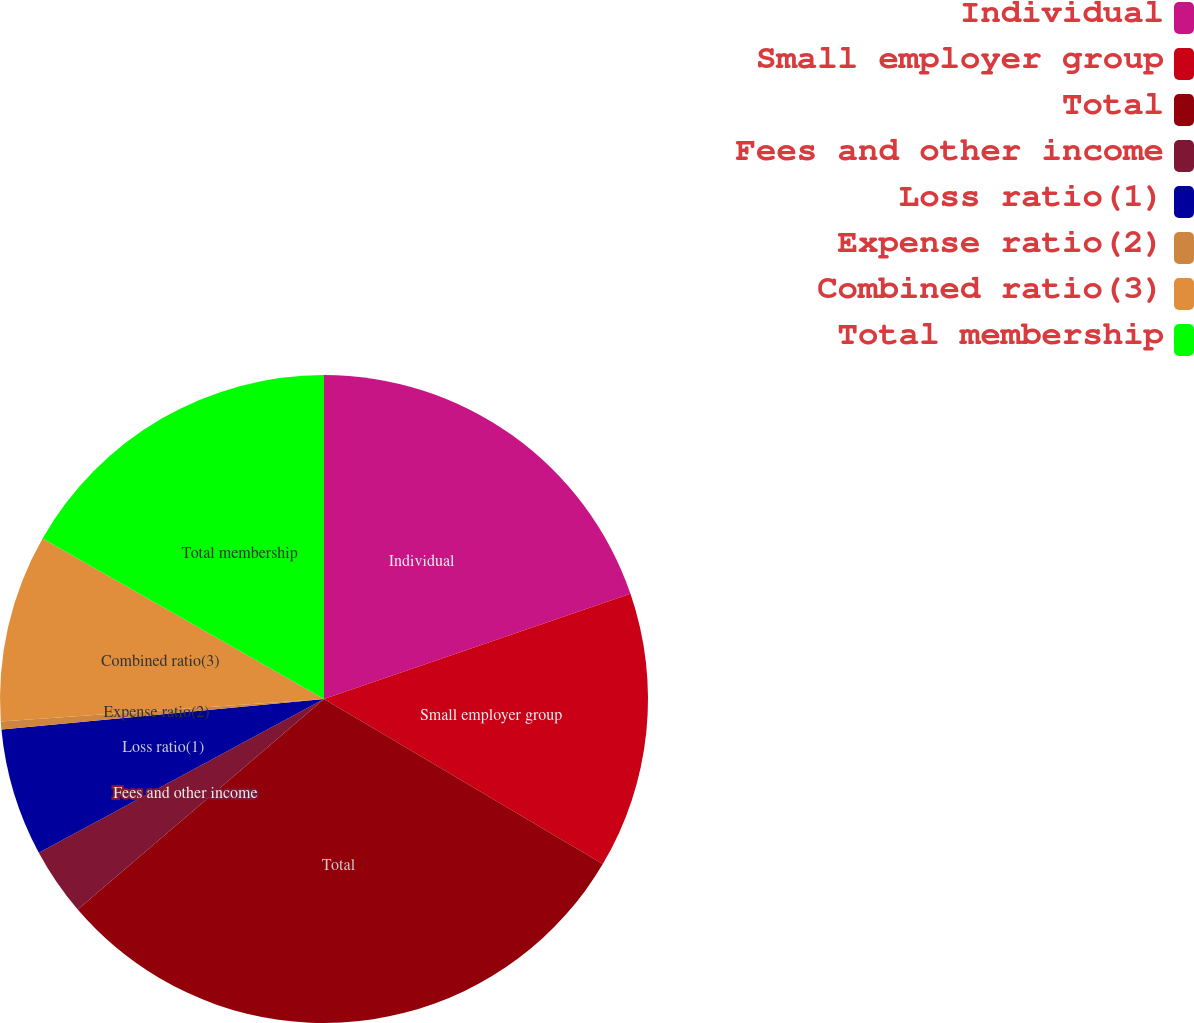Convert chart. <chart><loc_0><loc_0><loc_500><loc_500><pie_chart><fcel>Individual<fcel>Small employer group<fcel>Total<fcel>Fees and other income<fcel>Loss ratio(1)<fcel>Expense ratio(2)<fcel>Combined ratio(3)<fcel>Total membership<nl><fcel>19.74%<fcel>13.77%<fcel>30.23%<fcel>3.39%<fcel>6.37%<fcel>0.4%<fcel>9.35%<fcel>16.75%<nl></chart> 